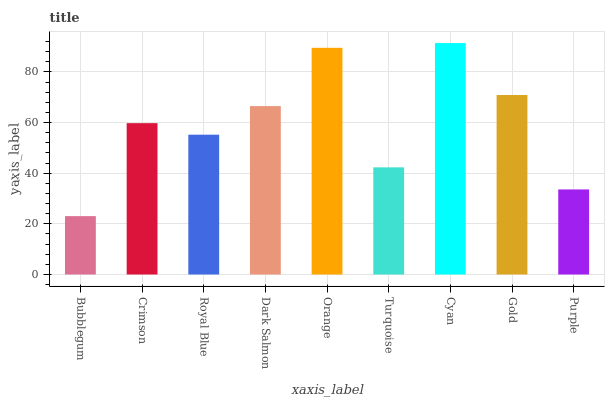Is Cyan the maximum?
Answer yes or no. Yes. Is Crimson the minimum?
Answer yes or no. No. Is Crimson the maximum?
Answer yes or no. No. Is Crimson greater than Bubblegum?
Answer yes or no. Yes. Is Bubblegum less than Crimson?
Answer yes or no. Yes. Is Bubblegum greater than Crimson?
Answer yes or no. No. Is Crimson less than Bubblegum?
Answer yes or no. No. Is Crimson the high median?
Answer yes or no. Yes. Is Crimson the low median?
Answer yes or no. Yes. Is Gold the high median?
Answer yes or no. No. Is Royal Blue the low median?
Answer yes or no. No. 